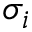<formula> <loc_0><loc_0><loc_500><loc_500>\sigma _ { i }</formula> 